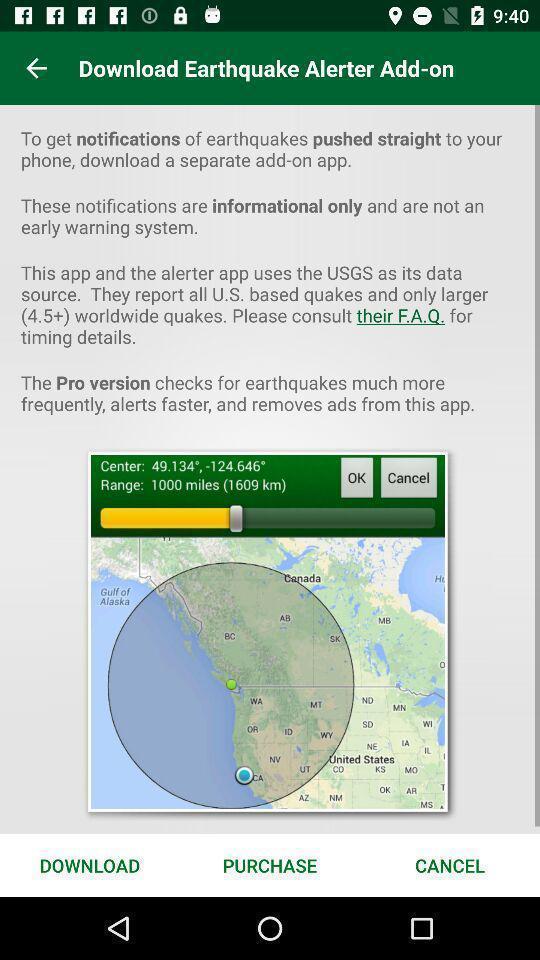Describe the content in this image. Page showing information about earthquake tracker app. 